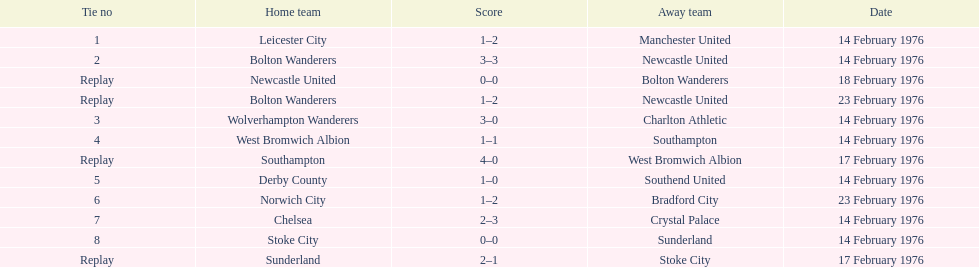What is the number of games that were played again? 4. 